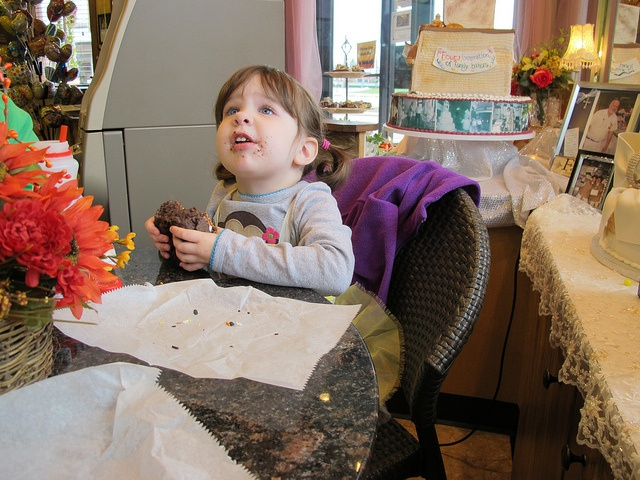Describe the objects in this image and their specific colors. I can see dining table in tan, darkgray, gray, and lightgray tones, refrigerator in tan, darkgray, and gray tones, people in tan, darkgray, lightgray, and gray tones, chair in tan, black, purple, maroon, and gray tones, and cake in tan, darkgray, and gray tones in this image. 